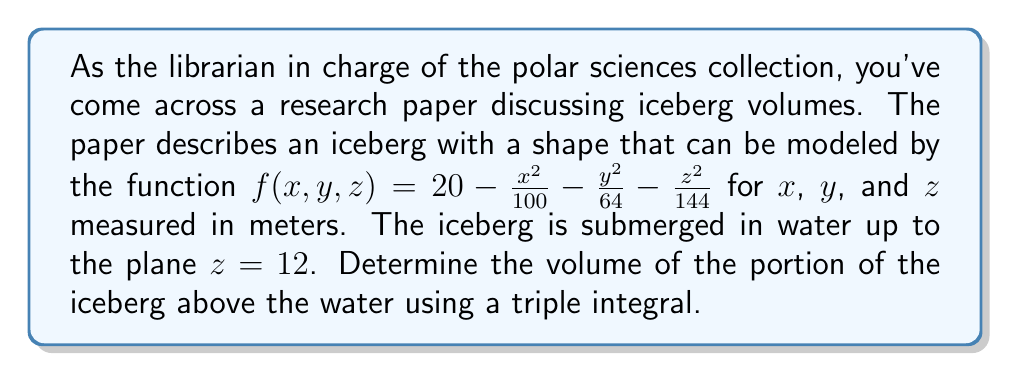Teach me how to tackle this problem. To solve this problem, we need to set up and evaluate a triple integral. Let's approach this step-by-step:

1) First, we need to determine the limits of integration. The iceberg's shape is defined by:

   $$20 - \frac{x^2}{100} - \frac{y^2}{64} - \frac{z^2}{144} = 0$$

2) From this, we can derive the limits for x, y, and z:

   $$x^2 \leq 100(20 - \frac{y^2}{64} - \frac{z^2}{144})$$
   $$y^2 \leq 64(20 - \frac{x^2}{100} - \frac{z^2}{144})$$
   $$z^2 \leq 144(20 - \frac{x^2}{100} - \frac{y^2}{64})$$

3) The portion above water starts at z = 12, so our z-limits are from 12 to the top of the iceberg.

4) We can set up the triple integral as follows:

   $$V = \iiint_V dV = \int_{-10}^{10} \int_{-y_{max}}^{y_{max}} \int_{12}^{z_{max}} dz dy dx$$

   Where:
   $$y_{max} = 8\sqrt{20 - \frac{x^2}{100} - \frac{144}{144}}$$
   $$z_{max} = 12\sqrt{20 - \frac{x^2}{100} - \frac{y^2}{64}}$$

5) Evaluating this integral:

   $$V = \int_{-10}^{10} \int_{-8\sqrt{16-\frac{x^2}{100}}}^{8\sqrt{16-\frac{x^2}{100}}} \int_{12}^{12\sqrt{20-\frac{x^2}{100}-\frac{y^2}{64}}} dz dy dx$$

6) Integrating with respect to z:

   $$V = \int_{-10}^{10} \int_{-8\sqrt{16-\frac{x^2}{100}}}^{8\sqrt{16-\frac{x^2}{100}}} [12\sqrt{20-\frac{x^2}{100}-\frac{y^2}{64}} - 12] dy dx$$

7) This integral can be evaluated numerically using computational methods.
Answer: The volume of the portion of the iceberg above water is approximately 3,351.03 cubic meters, calculated using numerical integration methods. 